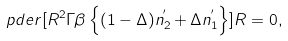<formula> <loc_0><loc_0><loc_500><loc_500>\ p d e r [ R ^ { 2 } \Gamma \beta \left \{ ( 1 - \Delta ) n _ { 2 } ^ { ^ { \prime } } + \Delta n _ { 1 } ^ { ^ { \prime } } \right \} ] { R } = 0 ,</formula> 